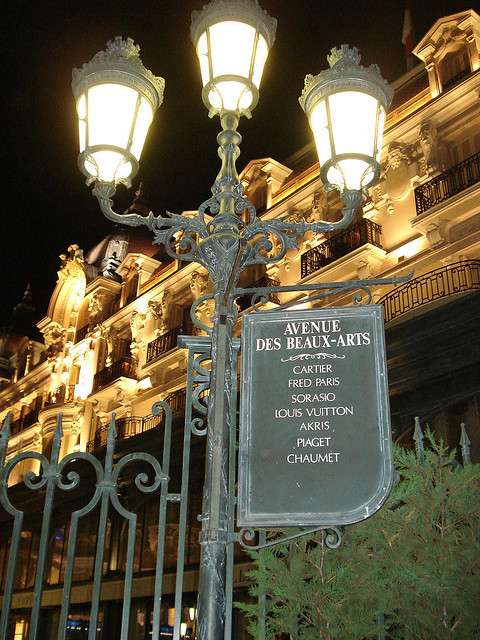Read and extract the text from this image. AVENUE DES BEAUX-ARTS CARTIER FRED PARIS CHAUMET PIAGET AKRIS VUITTON LOUIS SORASIO 